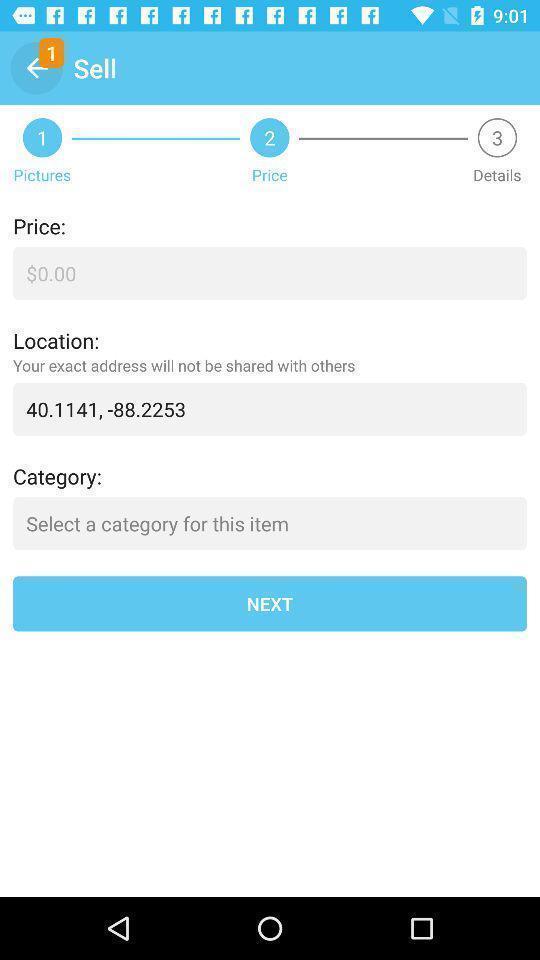Provide a detailed account of this screenshot. Page displaying the details for the pictures in shopping application. 